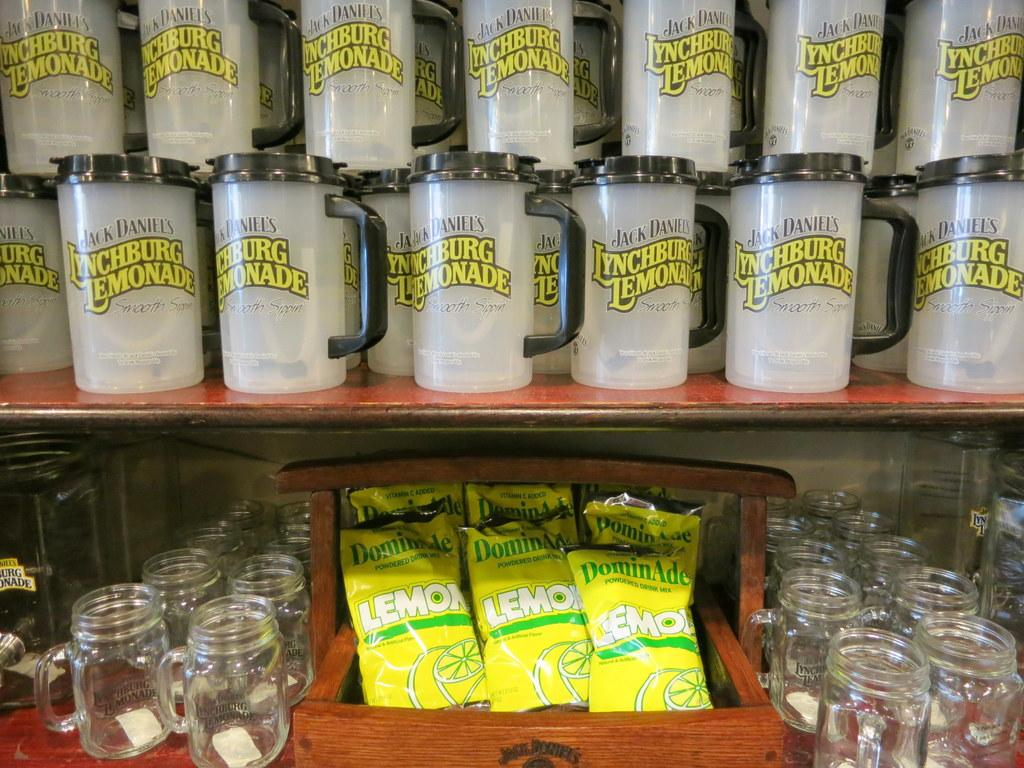<image>
Give a short and clear explanation of the subsequent image. a shelf stacked with jack daniels plactic mugs with lids 